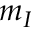<formula> <loc_0><loc_0><loc_500><loc_500>m _ { I }</formula> 